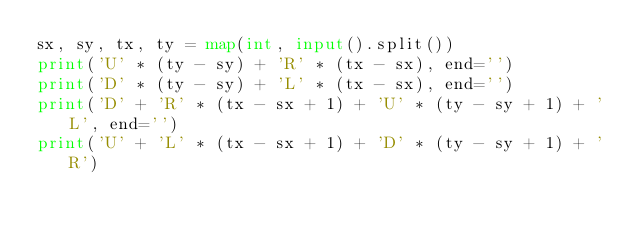Convert code to text. <code><loc_0><loc_0><loc_500><loc_500><_Python_>sx, sy, tx, ty = map(int, input().split())
print('U' * (ty - sy) + 'R' * (tx - sx), end='')
print('D' * (ty - sy) + 'L' * (tx - sx), end='')
print('D' + 'R' * (tx - sx + 1) + 'U' * (ty - sy + 1) + 'L', end='')
print('U' + 'L' * (tx - sx + 1) + 'D' * (ty - sy + 1) + 'R')</code> 